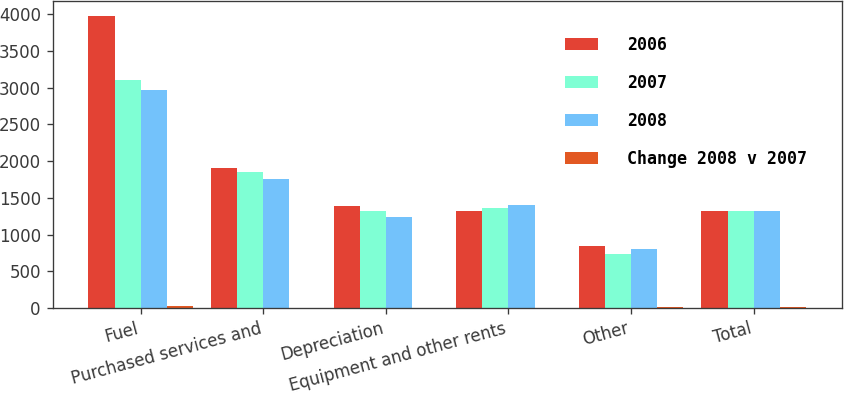<chart> <loc_0><loc_0><loc_500><loc_500><stacked_bar_chart><ecel><fcel>Fuel<fcel>Purchased services and<fcel>Depreciation<fcel>Equipment and other rents<fcel>Other<fcel>Total<nl><fcel>2006<fcel>3983<fcel>1902<fcel>1387<fcel>1326<fcel>840<fcel>1321<nl><fcel>2007<fcel>3104<fcel>1856<fcel>1321<fcel>1368<fcel>733<fcel>1321<nl><fcel>2008<fcel>2968<fcel>1756<fcel>1237<fcel>1396<fcel>802<fcel>1321<nl><fcel>Change 2008 v 2007<fcel>28<fcel>2<fcel>5<fcel>3<fcel>15<fcel>8<nl></chart> 